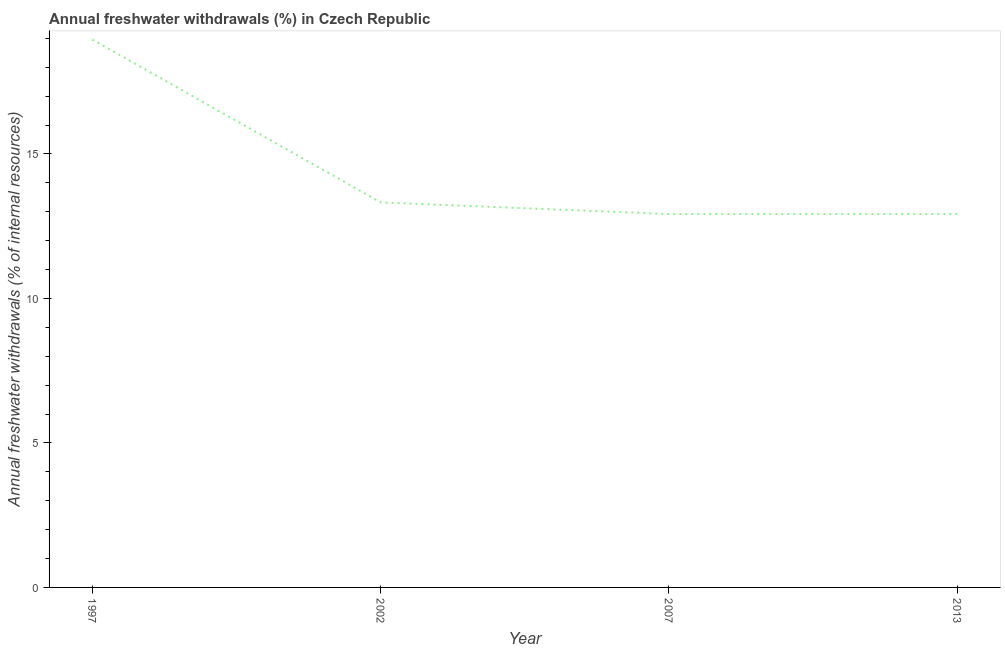What is the annual freshwater withdrawals in 2007?
Make the answer very short. 12.92. Across all years, what is the maximum annual freshwater withdrawals?
Provide a short and direct response. 18.96. Across all years, what is the minimum annual freshwater withdrawals?
Provide a short and direct response. 12.92. What is the sum of the annual freshwater withdrawals?
Ensure brevity in your answer.  58.12. What is the difference between the annual freshwater withdrawals in 1997 and 2007?
Your answer should be very brief. 6.04. What is the average annual freshwater withdrawals per year?
Ensure brevity in your answer.  14.53. What is the median annual freshwater withdrawals?
Your answer should be very brief. 13.12. In how many years, is the annual freshwater withdrawals greater than 1 %?
Give a very brief answer. 4. Do a majority of the years between 2013 and 2002 (inclusive) have annual freshwater withdrawals greater than 17 %?
Make the answer very short. No. What is the ratio of the annual freshwater withdrawals in 2002 to that in 2013?
Your response must be concise. 1.03. Is the difference between the annual freshwater withdrawals in 1997 and 2013 greater than the difference between any two years?
Provide a short and direct response. Yes. What is the difference between the highest and the second highest annual freshwater withdrawals?
Give a very brief answer. 5.63. Is the sum of the annual freshwater withdrawals in 2007 and 2013 greater than the maximum annual freshwater withdrawals across all years?
Offer a very short reply. Yes. What is the difference between the highest and the lowest annual freshwater withdrawals?
Your answer should be compact. 6.04. Does the annual freshwater withdrawals monotonically increase over the years?
Your response must be concise. No. How many lines are there?
Make the answer very short. 1. What is the difference between two consecutive major ticks on the Y-axis?
Your response must be concise. 5. Are the values on the major ticks of Y-axis written in scientific E-notation?
Your answer should be very brief. No. Does the graph contain any zero values?
Your answer should be very brief. No. Does the graph contain grids?
Offer a very short reply. No. What is the title of the graph?
Ensure brevity in your answer.  Annual freshwater withdrawals (%) in Czech Republic. What is the label or title of the Y-axis?
Your response must be concise. Annual freshwater withdrawals (% of internal resources). What is the Annual freshwater withdrawals (% of internal resources) in 1997?
Provide a short and direct response. 18.96. What is the Annual freshwater withdrawals (% of internal resources) in 2002?
Your answer should be compact. 13.32. What is the Annual freshwater withdrawals (% of internal resources) in 2007?
Provide a short and direct response. 12.92. What is the Annual freshwater withdrawals (% of internal resources) of 2013?
Ensure brevity in your answer.  12.92. What is the difference between the Annual freshwater withdrawals (% of internal resources) in 1997 and 2002?
Ensure brevity in your answer.  5.63. What is the difference between the Annual freshwater withdrawals (% of internal resources) in 1997 and 2007?
Offer a terse response. 6.04. What is the difference between the Annual freshwater withdrawals (% of internal resources) in 1997 and 2013?
Provide a short and direct response. 6.04. What is the difference between the Annual freshwater withdrawals (% of internal resources) in 2002 and 2007?
Make the answer very short. 0.4. What is the difference between the Annual freshwater withdrawals (% of internal resources) in 2002 and 2013?
Offer a terse response. 0.4. What is the ratio of the Annual freshwater withdrawals (% of internal resources) in 1997 to that in 2002?
Offer a terse response. 1.42. What is the ratio of the Annual freshwater withdrawals (% of internal resources) in 1997 to that in 2007?
Provide a succinct answer. 1.47. What is the ratio of the Annual freshwater withdrawals (% of internal resources) in 1997 to that in 2013?
Make the answer very short. 1.47. What is the ratio of the Annual freshwater withdrawals (% of internal resources) in 2002 to that in 2007?
Give a very brief answer. 1.03. What is the ratio of the Annual freshwater withdrawals (% of internal resources) in 2002 to that in 2013?
Offer a very short reply. 1.03. 